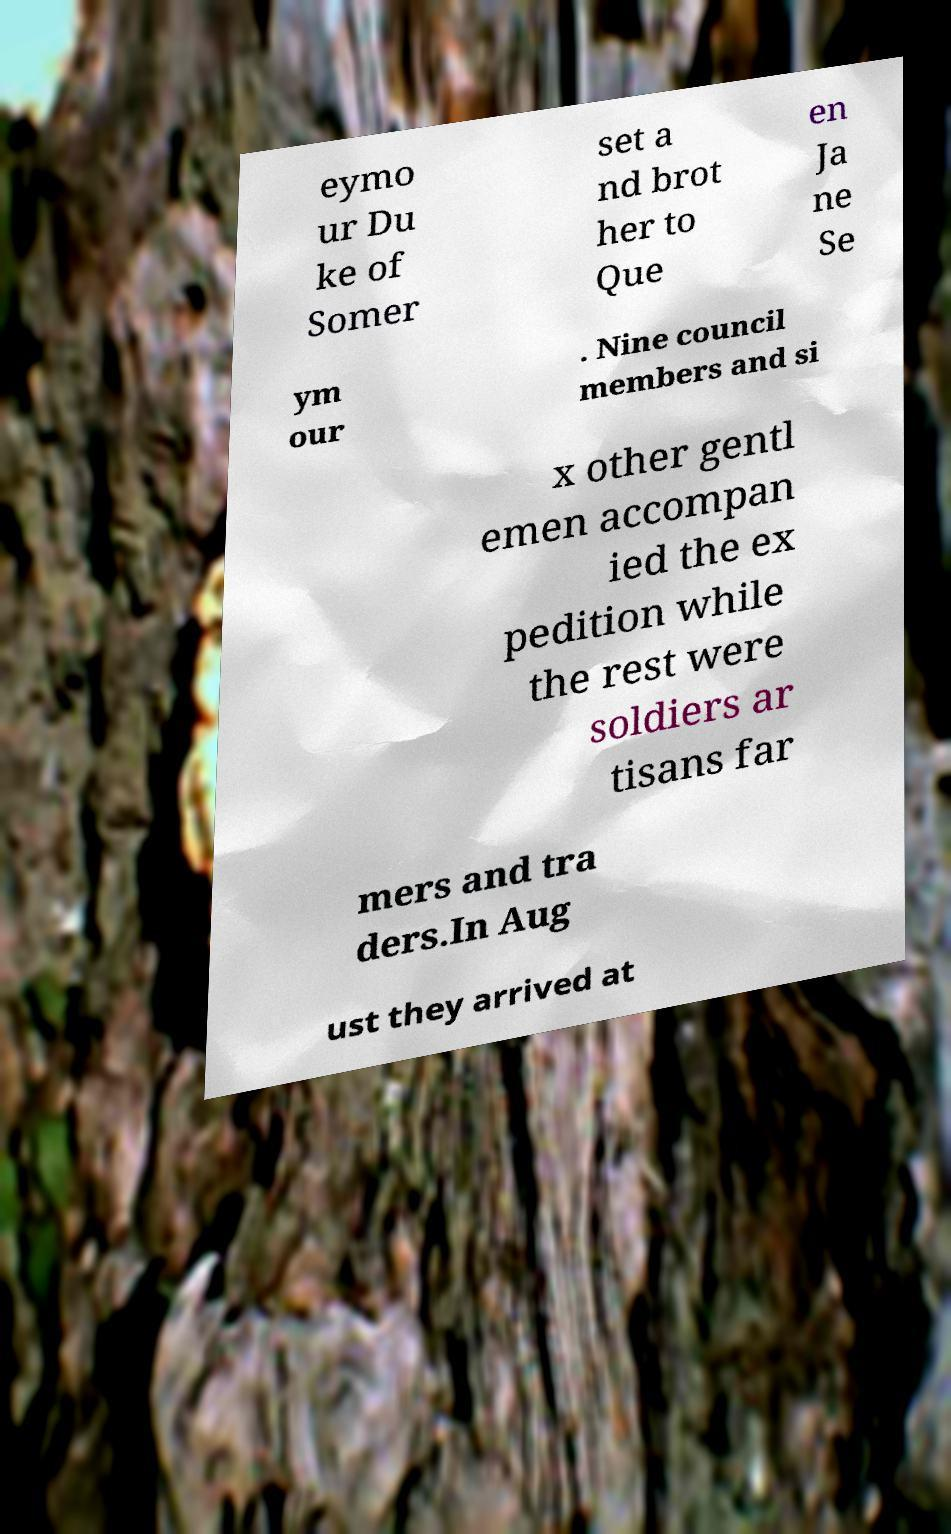I need the written content from this picture converted into text. Can you do that? eymo ur Du ke of Somer set a nd brot her to Que en Ja ne Se ym our . Nine council members and si x other gentl emen accompan ied the ex pedition while the rest were soldiers ar tisans far mers and tra ders.In Aug ust they arrived at 